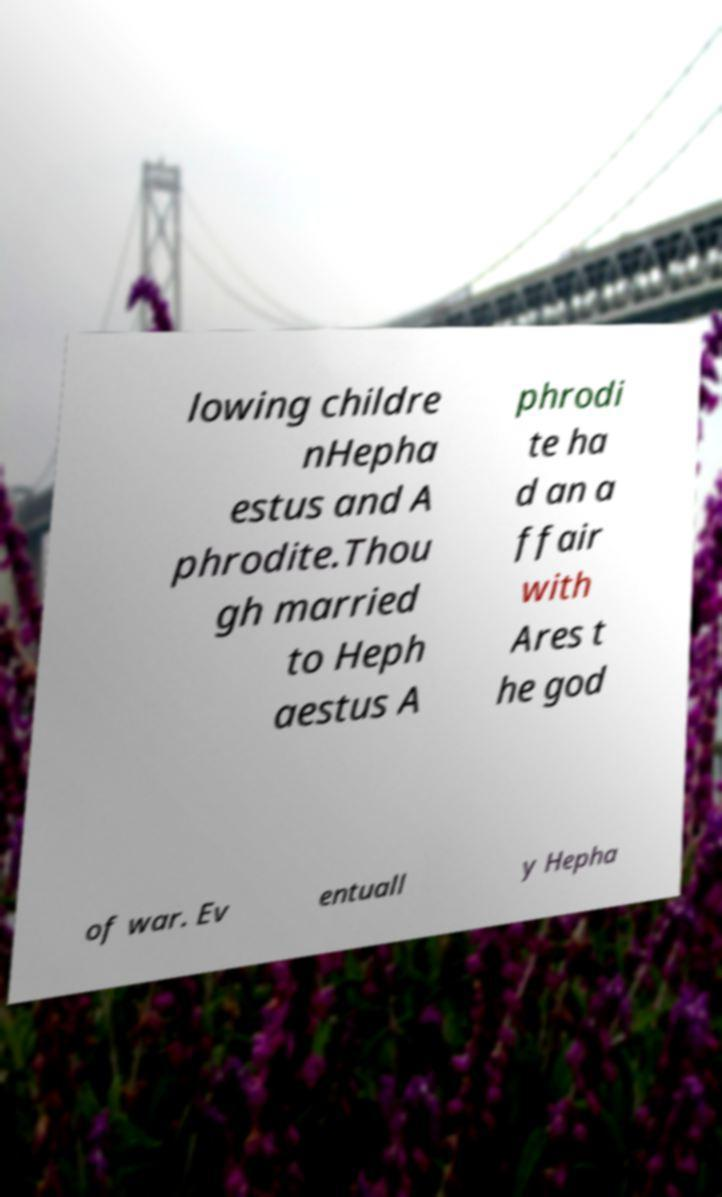I need the written content from this picture converted into text. Can you do that? lowing childre nHepha estus and A phrodite.Thou gh married to Heph aestus A phrodi te ha d an a ffair with Ares t he god of war. Ev entuall y Hepha 